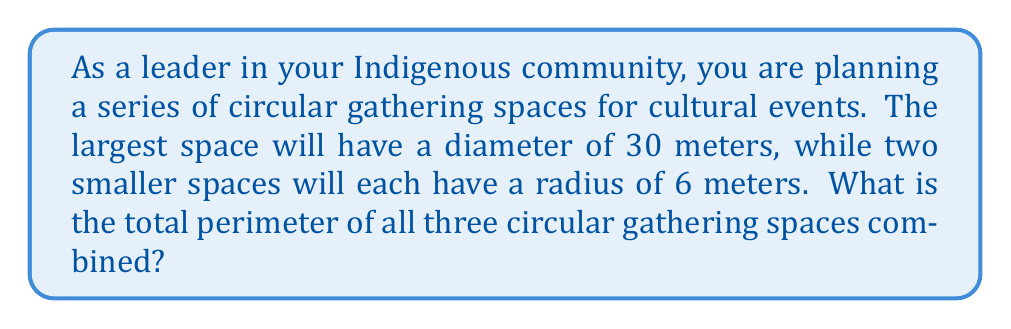Show me your answer to this math problem. Let's approach this problem step-by-step:

1) Recall the formula for the circumference (perimeter) of a circle:
   $$C = 2\pi r$$
   where $C$ is the circumference, $\pi$ is pi (approximately 3.14159), and $r$ is the radius.

2) For the largest space:
   - We're given the diameter (30 meters), so we need to halve this to get the radius.
   - Radius = 30 / 2 = 15 meters
   - Circumference = $2\pi(15)$ = $30\pi$ meters

3) For each of the smaller spaces:
   - We're given the radius (6 meters)
   - Circumference = $2\pi(6)$ = $12\pi$ meters

4) Since there are two smaller spaces, we need to calculate:
   Total perimeter = Largest space + 2 * (Smaller space)
                   = $30\pi + 2(12\pi)$
                   = $30\pi + 24\pi$
                   = $54\pi$ meters

5) If we want to express this as a decimal, we can multiply by $\pi$:
   $54\pi \approx 54 * 3.14159 \approx 169.65$ meters (rounded to 2 decimal places)

[asy]
unitsize(4mm);
draw(circle((0,0),15), rgb(0.7,0,0));
draw(circle((20,0),6), rgb(0,0.7,0));
draw(circle((35,0),6), rgb(0,0.7,0));
label("30m", (0,-16), S);
label("12m", (20,-7), S);
label("12m", (35,-7), S);
[/asy]

This diagram illustrates the three circular gathering spaces to scale.
Answer: The total perimeter of all three circular gathering spaces is $54\pi$ meters, or approximately 169.65 meters. 